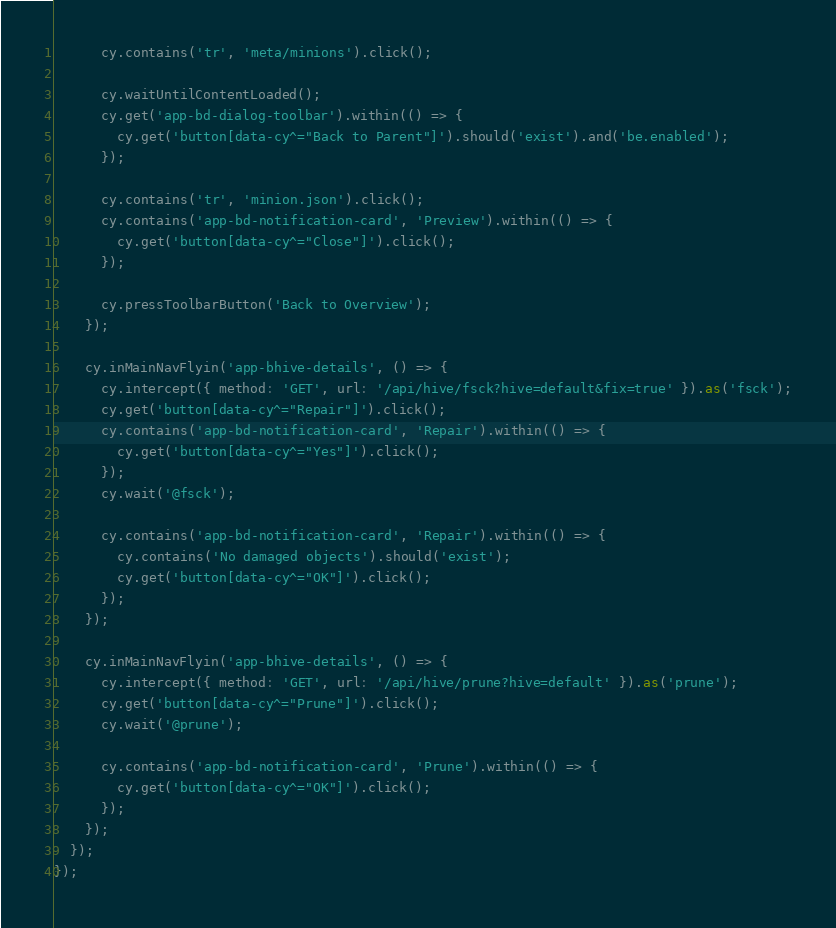<code> <loc_0><loc_0><loc_500><loc_500><_JavaScript_>      cy.contains('tr', 'meta/minions').click();

      cy.waitUntilContentLoaded();
      cy.get('app-bd-dialog-toolbar').within(() => {
        cy.get('button[data-cy^="Back to Parent"]').should('exist').and('be.enabled');
      });

      cy.contains('tr', 'minion.json').click();
      cy.contains('app-bd-notification-card', 'Preview').within(() => {
        cy.get('button[data-cy^="Close"]').click();
      });

      cy.pressToolbarButton('Back to Overview');
    });

    cy.inMainNavFlyin('app-bhive-details', () => {
      cy.intercept({ method: 'GET', url: '/api/hive/fsck?hive=default&fix=true' }).as('fsck');
      cy.get('button[data-cy^="Repair"]').click();
      cy.contains('app-bd-notification-card', 'Repair').within(() => {
        cy.get('button[data-cy^="Yes"]').click();
      });
      cy.wait('@fsck');

      cy.contains('app-bd-notification-card', 'Repair').within(() => {
        cy.contains('No damaged objects').should('exist');
        cy.get('button[data-cy^="OK"]').click();
      });
    });

    cy.inMainNavFlyin('app-bhive-details', () => {
      cy.intercept({ method: 'GET', url: '/api/hive/prune?hive=default' }).as('prune');
      cy.get('button[data-cy^="Prune"]').click();
      cy.wait('@prune');

      cy.contains('app-bd-notification-card', 'Prune').within(() => {
        cy.get('button[data-cy^="OK"]').click();
      });
    });
  });
});
</code> 